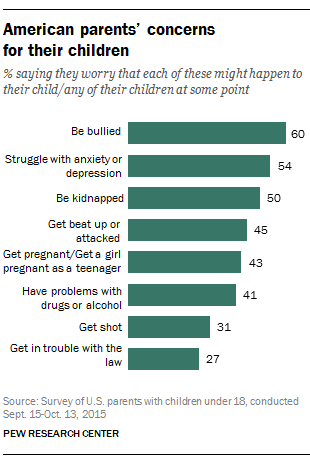Outline some significant characteristics in this image. The median bar is 44 inches in size. The second least concerned factor is being subtracted from the most concerned factor, resulting in a final number of 29. 